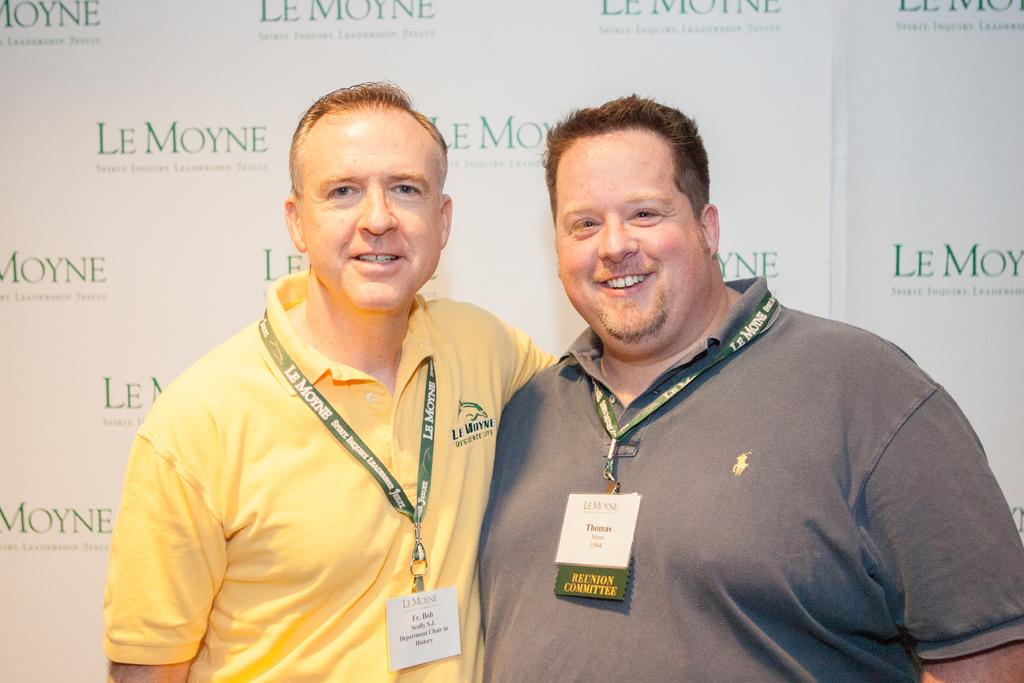How many people are present in the image? There are two people standing in the image. Can you describe the background of the image? There is a board in the background of the image. What type of church is depicted on the board in the image? There is no church depicted on the board in the image; it only features a board in the background. 